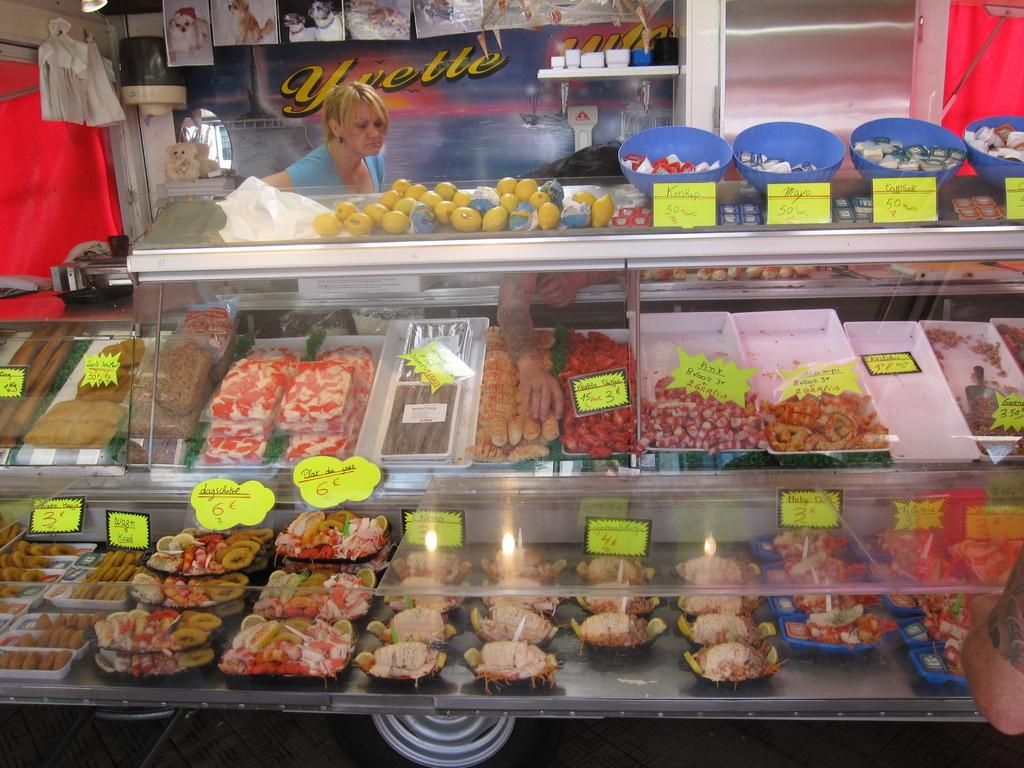<image>
Render a clear and concise summary of the photo. a woman stands looking at a shop display cabinet with poster for Yvette on it 